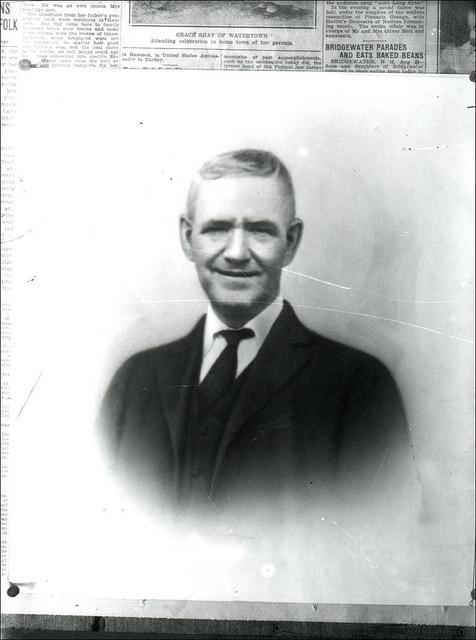Is that man still alive?
Write a very short answer. No. Was this picture taken recently?
Be succinct. No. Is this person wearing a tie?
Concise answer only. Yes. 